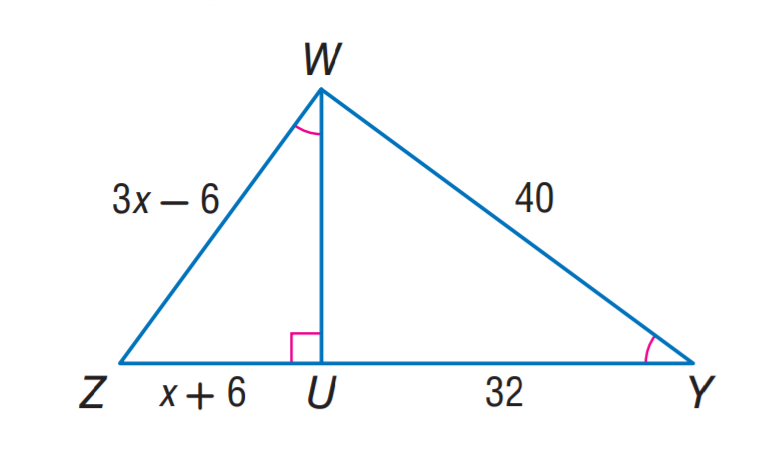Answer the mathemtical geometry problem and directly provide the correct option letter.
Question: Find W Z.
Choices: A: 18 B: 24 C: 30 D: 32 C 